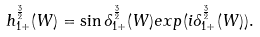<formula> <loc_0><loc_0><loc_500><loc_500>h _ { 1 + } ^ { \frac { 3 } { 2 } } ( W ) = \sin \delta _ { 1 + } ^ { \frac { 3 } { 2 } } ( W ) e x p ( i \delta _ { 1 + } ^ { \frac { 3 } { 2 } } ( W ) ) .</formula> 